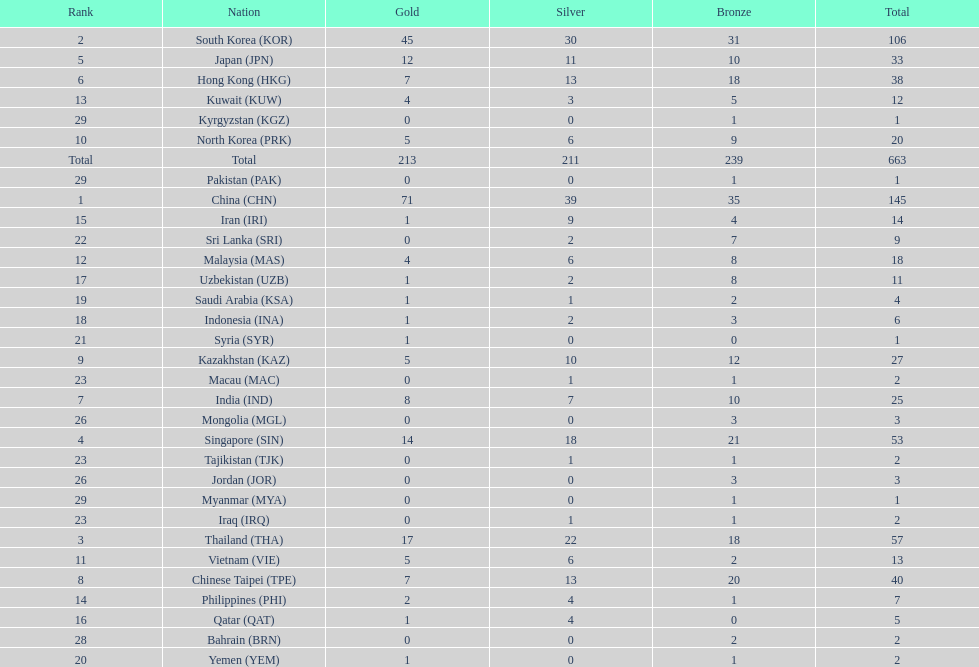What were the number of medals iran earned? 14. 